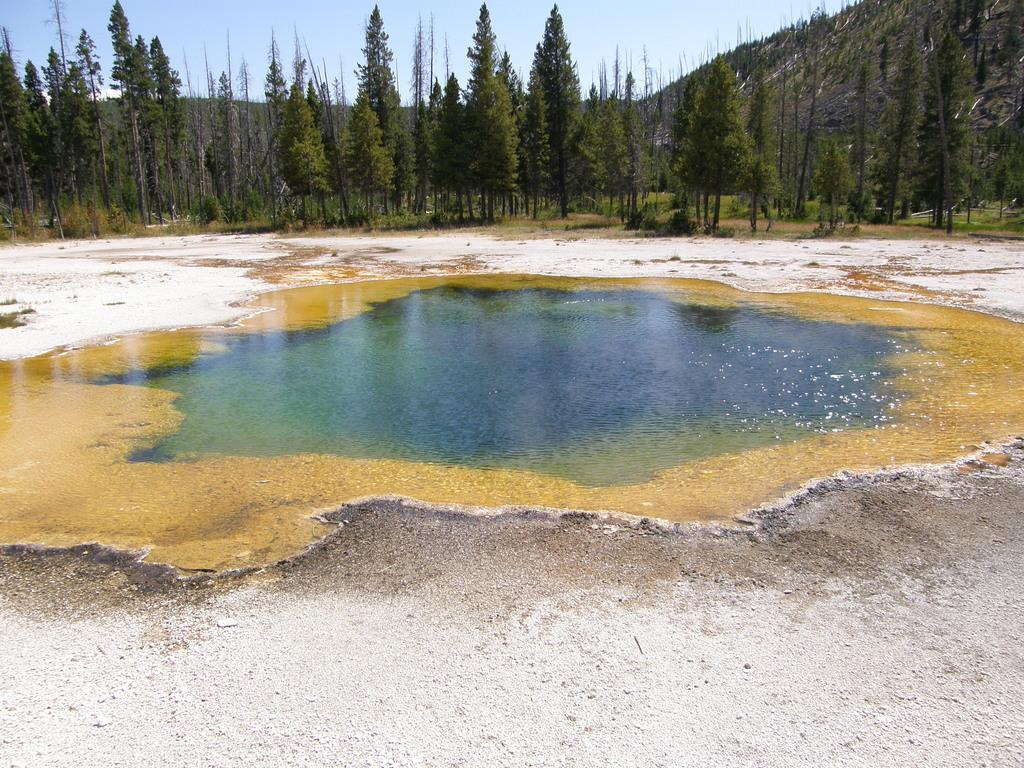What type of body of water is present in the image? There is a small pond in the image. Where is the pond located in relation to the foreground and background? The pond is located between the surface and the background. What can be seen in the background of the image? There are many trees and mountains in the background of the image. What type of dress is the rat wearing in the image? There is no rat or dress present in the image. 